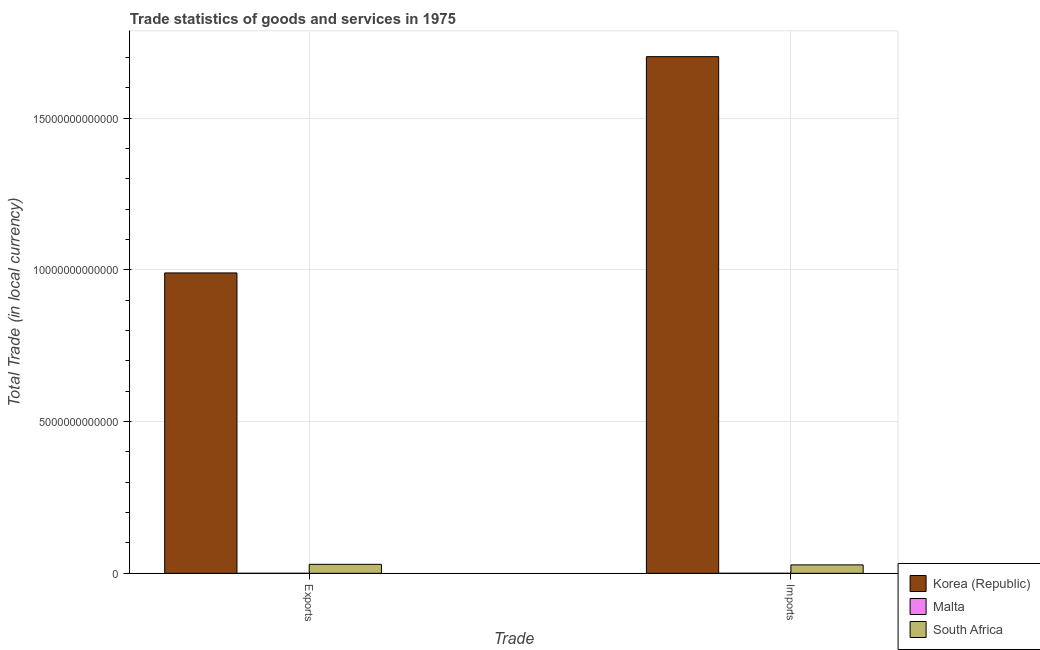How many groups of bars are there?
Ensure brevity in your answer.  2. Are the number of bars per tick equal to the number of legend labels?
Provide a short and direct response. Yes. How many bars are there on the 2nd tick from the right?
Make the answer very short. 3. What is the label of the 1st group of bars from the left?
Your answer should be compact. Exports. What is the export of goods and services in Korea (Republic)?
Keep it short and to the point. 9.90e+12. Across all countries, what is the maximum export of goods and services?
Offer a terse response. 9.90e+12. Across all countries, what is the minimum export of goods and services?
Provide a succinct answer. 1.13e+09. In which country was the export of goods and services minimum?
Provide a short and direct response. Malta. What is the total imports of goods and services in the graph?
Provide a short and direct response. 1.73e+13. What is the difference between the export of goods and services in Malta and that in Korea (Republic)?
Offer a terse response. -9.90e+12. What is the difference between the imports of goods and services in Korea (Republic) and the export of goods and services in South Africa?
Keep it short and to the point. 1.67e+13. What is the average export of goods and services per country?
Provide a succinct answer. 3.40e+12. What is the difference between the imports of goods and services and export of goods and services in Malta?
Give a very brief answer. 1.31e+08. What is the ratio of the imports of goods and services in Korea (Republic) to that in South Africa?
Your response must be concise. 61.2. Is the export of goods and services in Malta less than that in South Africa?
Offer a terse response. Yes. In how many countries, is the export of goods and services greater than the average export of goods and services taken over all countries?
Offer a terse response. 1. What does the 3rd bar from the left in Exports represents?
Provide a succinct answer. South Africa. What does the 3rd bar from the right in Imports represents?
Ensure brevity in your answer.  Korea (Republic). How many bars are there?
Your answer should be compact. 6. Are all the bars in the graph horizontal?
Provide a short and direct response. No. How many countries are there in the graph?
Your response must be concise. 3. What is the difference between two consecutive major ticks on the Y-axis?
Give a very brief answer. 5.00e+12. Are the values on the major ticks of Y-axis written in scientific E-notation?
Keep it short and to the point. No. Does the graph contain any zero values?
Offer a very short reply. No. Where does the legend appear in the graph?
Offer a terse response. Bottom right. How many legend labels are there?
Make the answer very short. 3. What is the title of the graph?
Make the answer very short. Trade statistics of goods and services in 1975. What is the label or title of the X-axis?
Offer a very short reply. Trade. What is the label or title of the Y-axis?
Your answer should be very brief. Total Trade (in local currency). What is the Total Trade (in local currency) of Korea (Republic) in Exports?
Make the answer very short. 9.90e+12. What is the Total Trade (in local currency) of Malta in Exports?
Give a very brief answer. 1.13e+09. What is the Total Trade (in local currency) of South Africa in Exports?
Your response must be concise. 2.97e+11. What is the Total Trade (in local currency) in Korea (Republic) in Imports?
Your answer should be very brief. 1.70e+13. What is the Total Trade (in local currency) of Malta in Imports?
Your answer should be very brief. 1.26e+09. What is the Total Trade (in local currency) of South Africa in Imports?
Make the answer very short. 2.78e+11. Across all Trade, what is the maximum Total Trade (in local currency) in Korea (Republic)?
Offer a terse response. 1.70e+13. Across all Trade, what is the maximum Total Trade (in local currency) of Malta?
Give a very brief answer. 1.26e+09. Across all Trade, what is the maximum Total Trade (in local currency) in South Africa?
Your answer should be compact. 2.97e+11. Across all Trade, what is the minimum Total Trade (in local currency) of Korea (Republic)?
Provide a succinct answer. 9.90e+12. Across all Trade, what is the minimum Total Trade (in local currency) in Malta?
Ensure brevity in your answer.  1.13e+09. Across all Trade, what is the minimum Total Trade (in local currency) in South Africa?
Your answer should be compact. 2.78e+11. What is the total Total Trade (in local currency) in Korea (Republic) in the graph?
Provide a succinct answer. 2.69e+13. What is the total Total Trade (in local currency) of Malta in the graph?
Ensure brevity in your answer.  2.38e+09. What is the total Total Trade (in local currency) in South Africa in the graph?
Provide a succinct answer. 5.75e+11. What is the difference between the Total Trade (in local currency) of Korea (Republic) in Exports and that in Imports?
Offer a very short reply. -7.13e+12. What is the difference between the Total Trade (in local currency) in Malta in Exports and that in Imports?
Provide a short and direct response. -1.31e+08. What is the difference between the Total Trade (in local currency) in South Africa in Exports and that in Imports?
Provide a succinct answer. 1.87e+1. What is the difference between the Total Trade (in local currency) of Korea (Republic) in Exports and the Total Trade (in local currency) of Malta in Imports?
Offer a terse response. 9.90e+12. What is the difference between the Total Trade (in local currency) in Korea (Republic) in Exports and the Total Trade (in local currency) in South Africa in Imports?
Make the answer very short. 9.62e+12. What is the difference between the Total Trade (in local currency) of Malta in Exports and the Total Trade (in local currency) of South Africa in Imports?
Your answer should be compact. -2.77e+11. What is the average Total Trade (in local currency) in Korea (Republic) per Trade?
Your answer should be very brief. 1.35e+13. What is the average Total Trade (in local currency) in Malta per Trade?
Provide a succinct answer. 1.19e+09. What is the average Total Trade (in local currency) in South Africa per Trade?
Provide a short and direct response. 2.87e+11. What is the difference between the Total Trade (in local currency) of Korea (Republic) and Total Trade (in local currency) of Malta in Exports?
Make the answer very short. 9.90e+12. What is the difference between the Total Trade (in local currency) of Korea (Republic) and Total Trade (in local currency) of South Africa in Exports?
Offer a very short reply. 9.60e+12. What is the difference between the Total Trade (in local currency) of Malta and Total Trade (in local currency) of South Africa in Exports?
Your response must be concise. -2.96e+11. What is the difference between the Total Trade (in local currency) of Korea (Republic) and Total Trade (in local currency) of Malta in Imports?
Ensure brevity in your answer.  1.70e+13. What is the difference between the Total Trade (in local currency) of Korea (Republic) and Total Trade (in local currency) of South Africa in Imports?
Keep it short and to the point. 1.67e+13. What is the difference between the Total Trade (in local currency) of Malta and Total Trade (in local currency) of South Africa in Imports?
Provide a short and direct response. -2.77e+11. What is the ratio of the Total Trade (in local currency) of Korea (Republic) in Exports to that in Imports?
Provide a short and direct response. 0.58. What is the ratio of the Total Trade (in local currency) in Malta in Exports to that in Imports?
Give a very brief answer. 0.9. What is the ratio of the Total Trade (in local currency) in South Africa in Exports to that in Imports?
Give a very brief answer. 1.07. What is the difference between the highest and the second highest Total Trade (in local currency) in Korea (Republic)?
Ensure brevity in your answer.  7.13e+12. What is the difference between the highest and the second highest Total Trade (in local currency) of Malta?
Make the answer very short. 1.31e+08. What is the difference between the highest and the second highest Total Trade (in local currency) of South Africa?
Give a very brief answer. 1.87e+1. What is the difference between the highest and the lowest Total Trade (in local currency) in Korea (Republic)?
Ensure brevity in your answer.  7.13e+12. What is the difference between the highest and the lowest Total Trade (in local currency) of Malta?
Keep it short and to the point. 1.31e+08. What is the difference between the highest and the lowest Total Trade (in local currency) in South Africa?
Your response must be concise. 1.87e+1. 